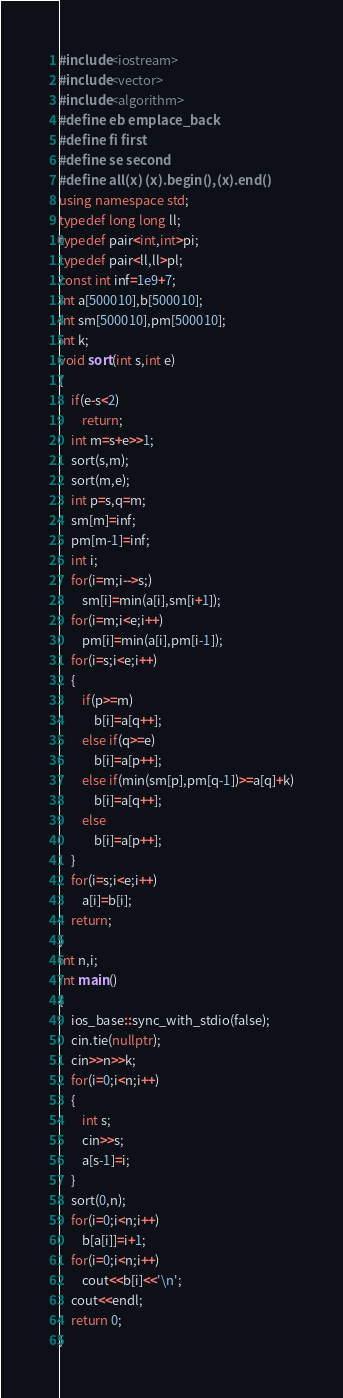Convert code to text. <code><loc_0><loc_0><loc_500><loc_500><_C++_>#include<iostream>
#include<vector>
#include<algorithm>
#define eb emplace_back
#define fi first
#define se second
#define all(x) (x).begin(),(x).end()
using namespace std;
typedef long long ll;
typedef pair<int,int>pi;
typedef pair<ll,ll>pl;
const int inf=1e9+7;
int a[500010],b[500010];
int sm[500010],pm[500010];
int k;
void sort(int s,int e)
{
    if(e-s<2)
        return;
    int m=s+e>>1;
    sort(s,m);
    sort(m,e);
    int p=s,q=m;
    sm[m]=inf;
    pm[m-1]=inf;
    int i;
    for(i=m;i-->s;)
        sm[i]=min(a[i],sm[i+1]);
    for(i=m;i<e;i++)
        pm[i]=min(a[i],pm[i-1]);
    for(i=s;i<e;i++)
    {
        if(p>=m)
            b[i]=a[q++];
        else if(q>=e)
            b[i]=a[p++];
        else if(min(sm[p],pm[q-1])>=a[q]+k)
            b[i]=a[q++];
        else
            b[i]=a[p++];
    }
    for(i=s;i<e;i++)
        a[i]=b[i];
    return;
}
int n,i;
int main()
{
    ios_base::sync_with_stdio(false);
    cin.tie(nullptr);
    cin>>n>>k;
    for(i=0;i<n;i++)
    {
        int s;
        cin>>s;
        a[s-1]=i;
    }
    sort(0,n);
    for(i=0;i<n;i++)
        b[a[i]]=i+1;
    for(i=0;i<n;i++)
        cout<<b[i]<<'\n';
    cout<<endl;
    return 0;
}</code> 